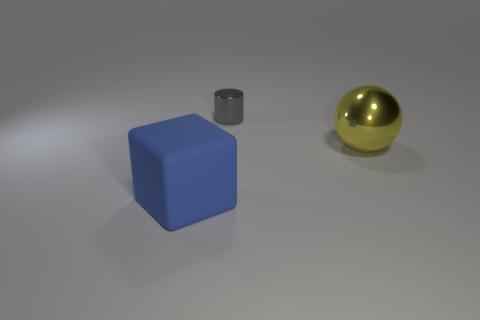What number of rubber things are either cyan cubes or tiny cylinders?
Your answer should be compact. 0. Are there more tiny gray cylinders that are right of the large metallic sphere than large balls on the left side of the cylinder?
Provide a succinct answer. No. How many other things are the same size as the cylinder?
Offer a very short reply. 0. What size is the thing in front of the shiny thing to the right of the tiny cylinder?
Make the answer very short. Large. How many tiny things are either metal things or blue cubes?
Provide a succinct answer. 1. What is the size of the yellow object in front of the thing behind the thing that is to the right of the shiny cylinder?
Your answer should be compact. Large. Is there any other thing of the same color as the large shiny thing?
Your response must be concise. No. What is the material of the thing that is behind the large thing that is behind the big object left of the metal sphere?
Your answer should be very brief. Metal. Do the large yellow thing and the rubber thing have the same shape?
Provide a succinct answer. No. Is there anything else that is the same material as the sphere?
Provide a succinct answer. Yes. 